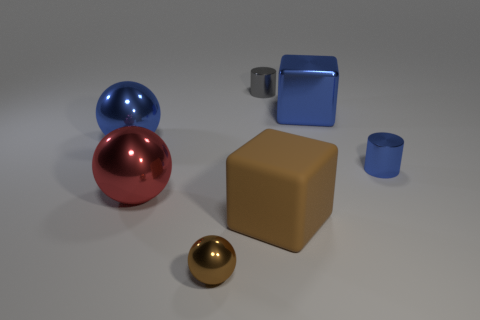Are there any other things that are made of the same material as the brown block?
Ensure brevity in your answer.  No. There is a tiny gray object that is the same shape as the small blue metal object; what is it made of?
Provide a succinct answer. Metal. What number of other objects are there of the same shape as the gray metallic thing?
Your response must be concise. 1. There is a gray object that is to the left of the small shiny cylinder that is on the right side of the gray cylinder; how many metal cylinders are on the left side of it?
Your answer should be compact. 0. How many large red objects have the same shape as the tiny brown metal thing?
Offer a very short reply. 1. Does the small thing that is to the right of the gray cylinder have the same color as the big rubber object?
Your response must be concise. No. The thing to the left of the big metallic ball that is in front of the blue metallic thing to the left of the tiny brown shiny ball is what shape?
Give a very brief answer. Sphere. There is a brown rubber object; is it the same size as the blue object on the left side of the tiny metal sphere?
Provide a succinct answer. Yes. Is there a red matte ball of the same size as the metal cube?
Give a very brief answer. No. What number of other objects are the same material as the small blue cylinder?
Make the answer very short. 5. 